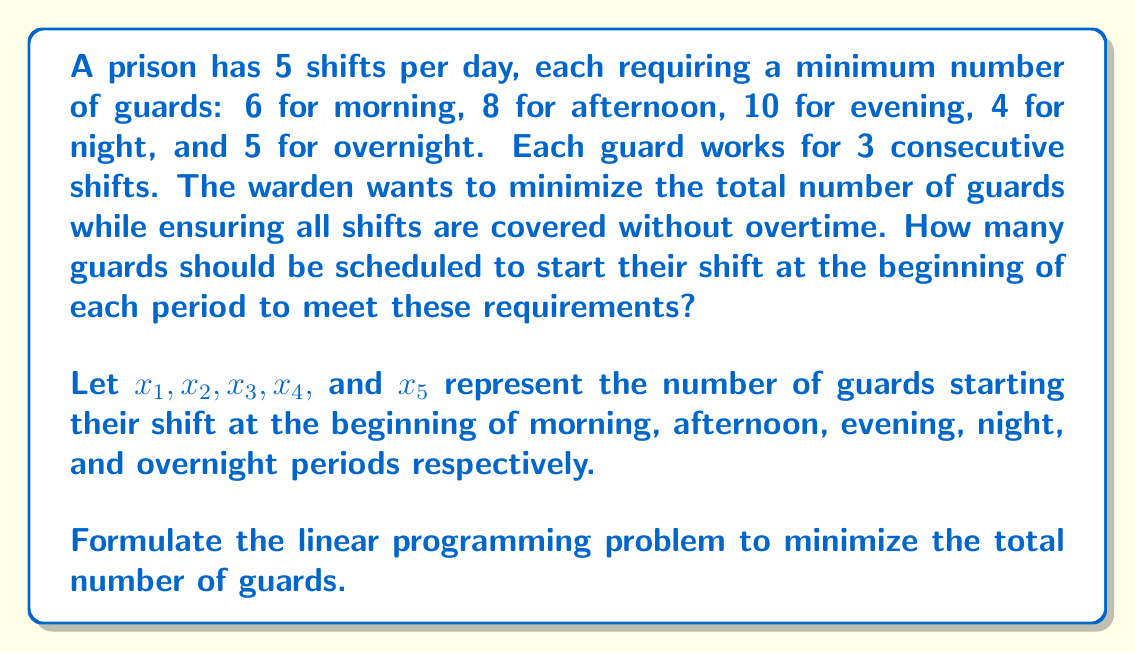Teach me how to tackle this problem. To formulate this linear programming problem, we need to:

1. Define the objective function
2. Set up the constraints
3. Include non-negativity constraints

1. Objective function:
The goal is to minimize the total number of guards, which is the sum of guards starting at each shift:

$$\text{Minimize } Z = x_1 + x_2 + x_3 + x_4 + x_5$$

2. Constraints:
For each shift, we need to ensure that the sum of guards working (those who started in that shift and the two previous shifts) is at least the minimum required:

Morning: $x_4 + x_5 + x_1 \geq 6$
Afternoon: $x_5 + x_1 + x_2 \geq 8$
Evening: $x_1 + x_2 + x_3 \geq 10$
Night: $x_2 + x_3 + x_4 \geq 4$
Overnight: $x_3 + x_4 + x_5 \geq 5$

3. Non-negativity constraints:
$x_1, x_2, x_3, x_4, x_5 \geq 0$

The complete linear programming formulation is:

$$\begin{align*}
\text{Minimize } Z &= x_1 + x_2 + x_3 + x_4 + x_5 \\
\text{Subject to:} \\
x_4 + x_5 + x_1 &\geq 6 \\
x_5 + x_1 + x_2 &\geq 8 \\
x_1 + x_2 + x_3 &\geq 10 \\
x_2 + x_3 + x_4 &\geq 4 \\
x_3 + x_4 + x_5 &\geq 5 \\
x_1, x_2, x_3, x_4, x_5 &\geq 0
\end{align*}$$

This formulation allows the warden to find the minimum number of guards needed while ensuring all shifts are covered without overtime, maintaining the current operational structure without introducing reforms.
Answer: The linear programming formulation to minimize the total number of guards while meeting shift requirements is:

$$\begin{align*}
\text{Minimize } Z &= x_1 + x_2 + x_3 + x_4 + x_5 \\
\text{Subject to:} \\
x_4 + x_5 + x_1 &\geq 6 \\
x_5 + x_1 + x_2 &\geq 8 \\
x_1 + x_2 + x_3 &\geq 10 \\
x_2 + x_3 + x_4 &\geq 4 \\
x_3 + x_4 + x_5 &\geq 5 \\
x_1, x_2, x_3, x_4, x_5 &\geq 0
\end{align*}$$ 